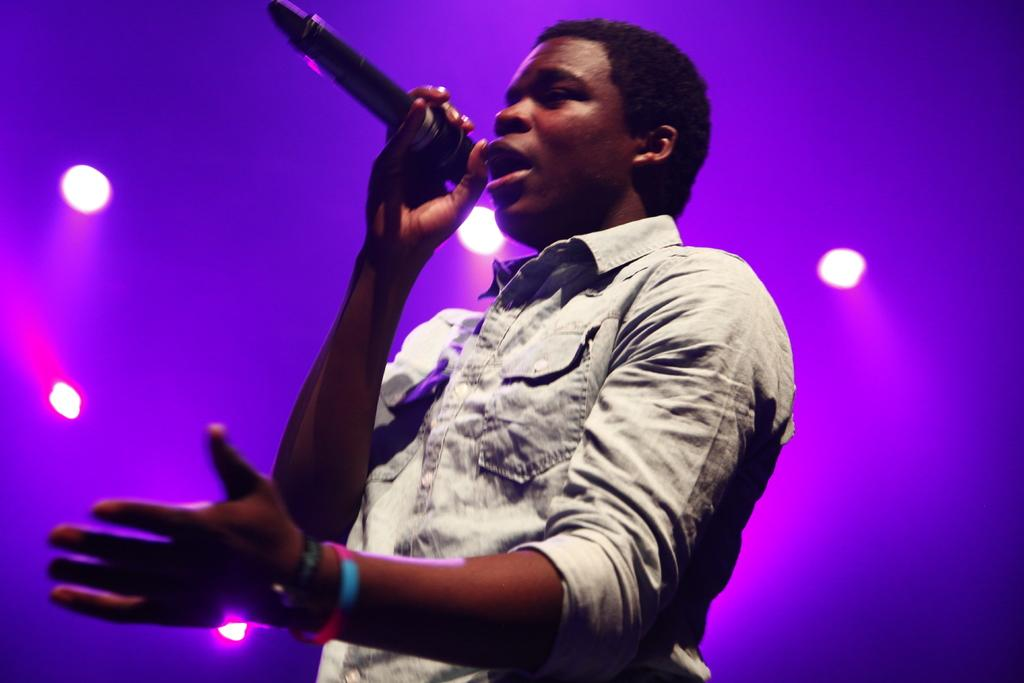Who is the main subject in the image? There is a man in the image. What is the man doing in the image? The man is standing and holding a mic. What can be seen in the background of the image? There are lights in the background of the image. What type of brush is the man using to clean the mice in the image? There is no brush or mice present in the image. The man is holding a mic and standing in front of lights. 